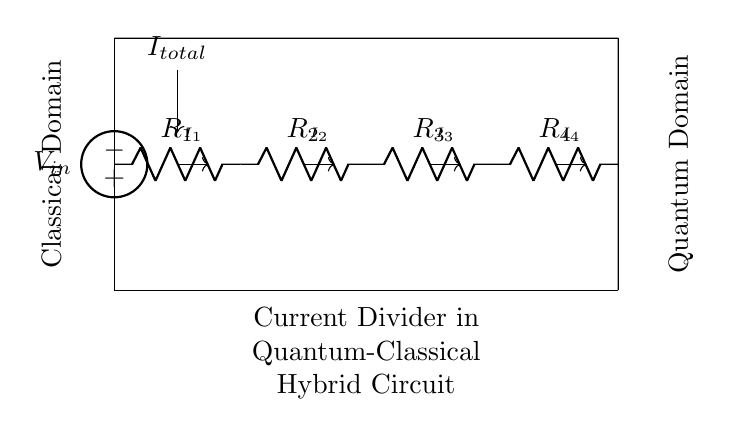what components are present in the circuit? The circuit contains an American voltage source and four resistors labeled R1, R2, R3, and R4. These components connect the input voltage to the output branches for the current division.
Answer: American voltage source, R1, R2, R3, R4 what is the total current entering the circuit? The total current entering the circuit is represented as I_total, which is displayed in the circuit diagram. It flows from the voltage source and splits into the current through each resistor.
Answer: I_total how many resistors are part of the current divider? There are four resistors (R1, R2, R3, R4) in the current divider, each positioned in series to create multiple paths for the total current to split.
Answer: Four what defines the current through R1? The current through R1, labeled as I1, is determined by the resistance value of R1 compared to the other resistors in the divider. The resistance affects how much of the total current I_total will flow through it.
Answer: The resistance of R1 if R3 has the highest resistance in this configuration, what can be inferred about I3? Since R3 has the highest resistance, Ohm’s law dictates that, among the resistors, it will have the smallest current I3 in the division arrangement. Higher resistance leads to lower current in parallel configurations.
Answer: I3 is the lowest what is the purpose of this circuit in a quantum-classical hybrid setup? This circuit serves to interface quantum processors with classical electronics by facilitating the controlled distribution of current to various parts of a measurement or feedback system, ensuring effective signal processing between quantum devices and classical components.
Answer: Interface with classical electronics 